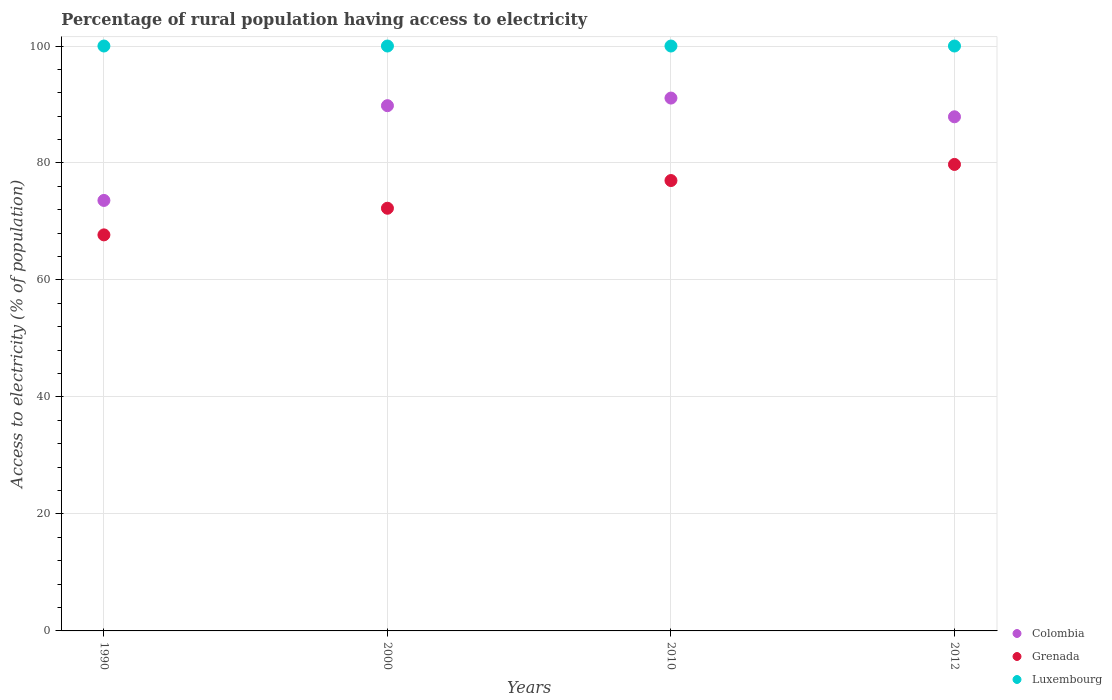How many different coloured dotlines are there?
Offer a terse response. 3. What is the percentage of rural population having access to electricity in Colombia in 2010?
Provide a short and direct response. 91.1. Across all years, what is the maximum percentage of rural population having access to electricity in Grenada?
Keep it short and to the point. 79.75. Across all years, what is the minimum percentage of rural population having access to electricity in Grenada?
Your response must be concise. 67.71. In which year was the percentage of rural population having access to electricity in Grenada maximum?
Ensure brevity in your answer.  2012. What is the total percentage of rural population having access to electricity in Luxembourg in the graph?
Your answer should be compact. 400. What is the difference between the percentage of rural population having access to electricity in Colombia in 2000 and that in 2012?
Give a very brief answer. 1.9. What is the difference between the percentage of rural population having access to electricity in Luxembourg in 2000 and the percentage of rural population having access to electricity in Grenada in 2012?
Offer a very short reply. 20.25. What is the average percentage of rural population having access to electricity in Colombia per year?
Offer a terse response. 85.6. In the year 1990, what is the difference between the percentage of rural population having access to electricity in Luxembourg and percentage of rural population having access to electricity in Colombia?
Make the answer very short. 26.4. In how many years, is the percentage of rural population having access to electricity in Colombia greater than 16 %?
Your response must be concise. 4. What is the ratio of the percentage of rural population having access to electricity in Colombia in 1990 to that in 2000?
Offer a terse response. 0.82. Is the percentage of rural population having access to electricity in Colombia in 1990 less than that in 2000?
Give a very brief answer. Yes. Is the difference between the percentage of rural population having access to electricity in Luxembourg in 2000 and 2012 greater than the difference between the percentage of rural population having access to electricity in Colombia in 2000 and 2012?
Make the answer very short. No. What is the difference between the highest and the second highest percentage of rural population having access to electricity in Grenada?
Ensure brevity in your answer.  2.75. Is the sum of the percentage of rural population having access to electricity in Colombia in 1990 and 2000 greater than the maximum percentage of rural population having access to electricity in Luxembourg across all years?
Make the answer very short. Yes. Is it the case that in every year, the sum of the percentage of rural population having access to electricity in Luxembourg and percentage of rural population having access to electricity in Colombia  is greater than the percentage of rural population having access to electricity in Grenada?
Give a very brief answer. Yes. Is the percentage of rural population having access to electricity in Colombia strictly less than the percentage of rural population having access to electricity in Luxembourg over the years?
Provide a succinct answer. Yes. Are the values on the major ticks of Y-axis written in scientific E-notation?
Ensure brevity in your answer.  No. Does the graph contain grids?
Ensure brevity in your answer.  Yes. How many legend labels are there?
Ensure brevity in your answer.  3. How are the legend labels stacked?
Your answer should be compact. Vertical. What is the title of the graph?
Keep it short and to the point. Percentage of rural population having access to electricity. What is the label or title of the X-axis?
Your answer should be compact. Years. What is the label or title of the Y-axis?
Your answer should be very brief. Access to electricity (% of population). What is the Access to electricity (% of population) of Colombia in 1990?
Provide a succinct answer. 73.6. What is the Access to electricity (% of population) of Grenada in 1990?
Offer a very short reply. 67.71. What is the Access to electricity (% of population) in Colombia in 2000?
Keep it short and to the point. 89.8. What is the Access to electricity (% of population) of Grenada in 2000?
Your answer should be compact. 72.27. What is the Access to electricity (% of population) in Luxembourg in 2000?
Provide a succinct answer. 100. What is the Access to electricity (% of population) in Colombia in 2010?
Your response must be concise. 91.1. What is the Access to electricity (% of population) in Grenada in 2010?
Your response must be concise. 77. What is the Access to electricity (% of population) in Luxembourg in 2010?
Give a very brief answer. 100. What is the Access to electricity (% of population) in Colombia in 2012?
Your response must be concise. 87.9. What is the Access to electricity (% of population) in Grenada in 2012?
Keep it short and to the point. 79.75. What is the Access to electricity (% of population) of Luxembourg in 2012?
Offer a very short reply. 100. Across all years, what is the maximum Access to electricity (% of population) in Colombia?
Offer a very short reply. 91.1. Across all years, what is the maximum Access to electricity (% of population) in Grenada?
Give a very brief answer. 79.75. Across all years, what is the maximum Access to electricity (% of population) in Luxembourg?
Offer a very short reply. 100. Across all years, what is the minimum Access to electricity (% of population) in Colombia?
Your response must be concise. 73.6. Across all years, what is the minimum Access to electricity (% of population) of Grenada?
Your answer should be very brief. 67.71. Across all years, what is the minimum Access to electricity (% of population) of Luxembourg?
Keep it short and to the point. 100. What is the total Access to electricity (% of population) in Colombia in the graph?
Keep it short and to the point. 342.4. What is the total Access to electricity (% of population) in Grenada in the graph?
Provide a succinct answer. 296.73. What is the difference between the Access to electricity (% of population) in Colombia in 1990 and that in 2000?
Make the answer very short. -16.2. What is the difference between the Access to electricity (% of population) in Grenada in 1990 and that in 2000?
Your answer should be very brief. -4.55. What is the difference between the Access to electricity (% of population) in Luxembourg in 1990 and that in 2000?
Keep it short and to the point. 0. What is the difference between the Access to electricity (% of population) in Colombia in 1990 and that in 2010?
Provide a succinct answer. -17.5. What is the difference between the Access to electricity (% of population) in Grenada in 1990 and that in 2010?
Provide a succinct answer. -9.29. What is the difference between the Access to electricity (% of population) in Luxembourg in 1990 and that in 2010?
Make the answer very short. 0. What is the difference between the Access to electricity (% of population) in Colombia in 1990 and that in 2012?
Your answer should be very brief. -14.3. What is the difference between the Access to electricity (% of population) in Grenada in 1990 and that in 2012?
Give a very brief answer. -12.04. What is the difference between the Access to electricity (% of population) in Grenada in 2000 and that in 2010?
Give a very brief answer. -4.74. What is the difference between the Access to electricity (% of population) of Grenada in 2000 and that in 2012?
Your answer should be very brief. -7.49. What is the difference between the Access to electricity (% of population) in Luxembourg in 2000 and that in 2012?
Ensure brevity in your answer.  0. What is the difference between the Access to electricity (% of population) in Colombia in 2010 and that in 2012?
Your answer should be compact. 3.2. What is the difference between the Access to electricity (% of population) of Grenada in 2010 and that in 2012?
Offer a terse response. -2.75. What is the difference between the Access to electricity (% of population) of Colombia in 1990 and the Access to electricity (% of population) of Grenada in 2000?
Your response must be concise. 1.33. What is the difference between the Access to electricity (% of population) in Colombia in 1990 and the Access to electricity (% of population) in Luxembourg in 2000?
Keep it short and to the point. -26.4. What is the difference between the Access to electricity (% of population) of Grenada in 1990 and the Access to electricity (% of population) of Luxembourg in 2000?
Your response must be concise. -32.29. What is the difference between the Access to electricity (% of population) of Colombia in 1990 and the Access to electricity (% of population) of Grenada in 2010?
Keep it short and to the point. -3.4. What is the difference between the Access to electricity (% of population) in Colombia in 1990 and the Access to electricity (% of population) in Luxembourg in 2010?
Provide a short and direct response. -26.4. What is the difference between the Access to electricity (% of population) of Grenada in 1990 and the Access to electricity (% of population) of Luxembourg in 2010?
Provide a succinct answer. -32.29. What is the difference between the Access to electricity (% of population) in Colombia in 1990 and the Access to electricity (% of population) in Grenada in 2012?
Offer a terse response. -6.15. What is the difference between the Access to electricity (% of population) of Colombia in 1990 and the Access to electricity (% of population) of Luxembourg in 2012?
Provide a succinct answer. -26.4. What is the difference between the Access to electricity (% of population) of Grenada in 1990 and the Access to electricity (% of population) of Luxembourg in 2012?
Ensure brevity in your answer.  -32.29. What is the difference between the Access to electricity (% of population) in Colombia in 2000 and the Access to electricity (% of population) in Grenada in 2010?
Provide a short and direct response. 12.8. What is the difference between the Access to electricity (% of population) in Grenada in 2000 and the Access to electricity (% of population) in Luxembourg in 2010?
Your answer should be compact. -27.73. What is the difference between the Access to electricity (% of population) of Colombia in 2000 and the Access to electricity (% of population) of Grenada in 2012?
Keep it short and to the point. 10.05. What is the difference between the Access to electricity (% of population) in Grenada in 2000 and the Access to electricity (% of population) in Luxembourg in 2012?
Your response must be concise. -27.73. What is the difference between the Access to electricity (% of population) in Colombia in 2010 and the Access to electricity (% of population) in Grenada in 2012?
Provide a short and direct response. 11.35. What is the average Access to electricity (% of population) in Colombia per year?
Provide a succinct answer. 85.6. What is the average Access to electricity (% of population) in Grenada per year?
Ensure brevity in your answer.  74.18. In the year 1990, what is the difference between the Access to electricity (% of population) in Colombia and Access to electricity (% of population) in Grenada?
Provide a succinct answer. 5.89. In the year 1990, what is the difference between the Access to electricity (% of population) in Colombia and Access to electricity (% of population) in Luxembourg?
Your answer should be very brief. -26.4. In the year 1990, what is the difference between the Access to electricity (% of population) in Grenada and Access to electricity (% of population) in Luxembourg?
Give a very brief answer. -32.29. In the year 2000, what is the difference between the Access to electricity (% of population) of Colombia and Access to electricity (% of population) of Grenada?
Offer a very short reply. 17.54. In the year 2000, what is the difference between the Access to electricity (% of population) of Grenada and Access to electricity (% of population) of Luxembourg?
Ensure brevity in your answer.  -27.73. In the year 2010, what is the difference between the Access to electricity (% of population) of Colombia and Access to electricity (% of population) of Grenada?
Your answer should be compact. 14.1. In the year 2010, what is the difference between the Access to electricity (% of population) of Colombia and Access to electricity (% of population) of Luxembourg?
Your response must be concise. -8.9. In the year 2012, what is the difference between the Access to electricity (% of population) in Colombia and Access to electricity (% of population) in Grenada?
Provide a short and direct response. 8.15. In the year 2012, what is the difference between the Access to electricity (% of population) in Grenada and Access to electricity (% of population) in Luxembourg?
Offer a terse response. -20.25. What is the ratio of the Access to electricity (% of population) in Colombia in 1990 to that in 2000?
Provide a succinct answer. 0.82. What is the ratio of the Access to electricity (% of population) of Grenada in 1990 to that in 2000?
Offer a terse response. 0.94. What is the ratio of the Access to electricity (% of population) of Luxembourg in 1990 to that in 2000?
Your answer should be very brief. 1. What is the ratio of the Access to electricity (% of population) of Colombia in 1990 to that in 2010?
Offer a terse response. 0.81. What is the ratio of the Access to electricity (% of population) of Grenada in 1990 to that in 2010?
Make the answer very short. 0.88. What is the ratio of the Access to electricity (% of population) of Luxembourg in 1990 to that in 2010?
Provide a succinct answer. 1. What is the ratio of the Access to electricity (% of population) in Colombia in 1990 to that in 2012?
Your answer should be very brief. 0.84. What is the ratio of the Access to electricity (% of population) in Grenada in 1990 to that in 2012?
Your response must be concise. 0.85. What is the ratio of the Access to electricity (% of population) of Colombia in 2000 to that in 2010?
Offer a very short reply. 0.99. What is the ratio of the Access to electricity (% of population) in Grenada in 2000 to that in 2010?
Provide a succinct answer. 0.94. What is the ratio of the Access to electricity (% of population) in Colombia in 2000 to that in 2012?
Your response must be concise. 1.02. What is the ratio of the Access to electricity (% of population) of Grenada in 2000 to that in 2012?
Provide a succinct answer. 0.91. What is the ratio of the Access to electricity (% of population) of Luxembourg in 2000 to that in 2012?
Make the answer very short. 1. What is the ratio of the Access to electricity (% of population) of Colombia in 2010 to that in 2012?
Offer a terse response. 1.04. What is the ratio of the Access to electricity (% of population) in Grenada in 2010 to that in 2012?
Give a very brief answer. 0.97. What is the ratio of the Access to electricity (% of population) of Luxembourg in 2010 to that in 2012?
Make the answer very short. 1. What is the difference between the highest and the second highest Access to electricity (% of population) of Colombia?
Your answer should be compact. 1.3. What is the difference between the highest and the second highest Access to electricity (% of population) of Grenada?
Your answer should be very brief. 2.75. What is the difference between the highest and the second highest Access to electricity (% of population) in Luxembourg?
Keep it short and to the point. 0. What is the difference between the highest and the lowest Access to electricity (% of population) of Grenada?
Your answer should be very brief. 12.04. 